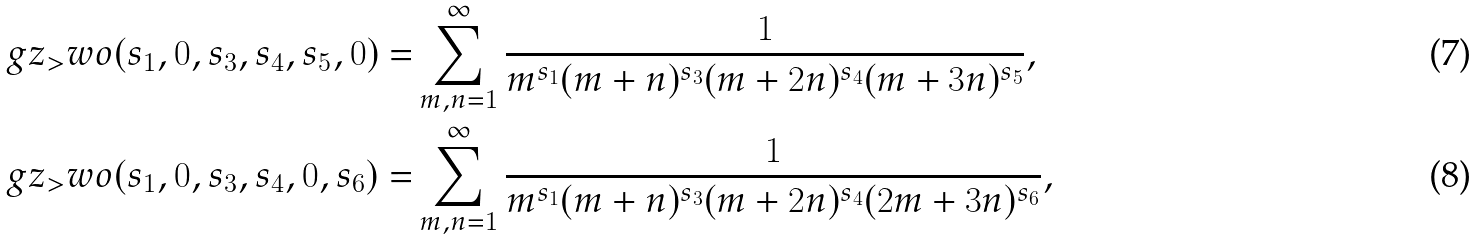Convert formula to latex. <formula><loc_0><loc_0><loc_500><loc_500>\ g z _ { > } w o ( s _ { 1 } , 0 , s _ { 3 } , s _ { 4 } , s _ { 5 } , 0 ) = & \sum _ { m , n = 1 } ^ { \infty } \frac { 1 } { m ^ { s _ { 1 } } ( m + n ) ^ { s _ { 3 } } ( m + 2 n ) ^ { s _ { 4 } } ( m + 3 n ) ^ { s _ { 5 } } } , \\ \ g z _ { > } w o ( s _ { 1 } , 0 , s _ { 3 } , s _ { 4 } , 0 , s _ { 6 } ) = & \sum _ { m , n = 1 } ^ { \infty } \frac { 1 } { m ^ { s _ { 1 } } ( m + n ) ^ { s _ { 3 } } ( m + 2 n ) ^ { s _ { 4 } } ( 2 m + 3 n ) ^ { s _ { 6 } } } ,</formula> 